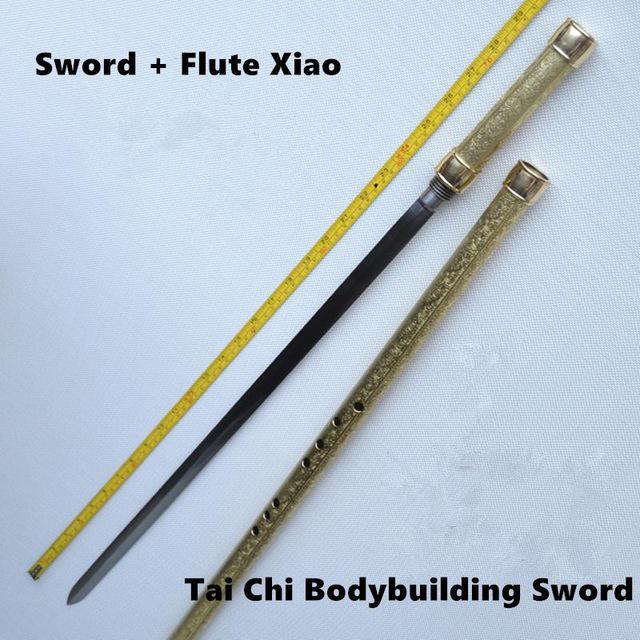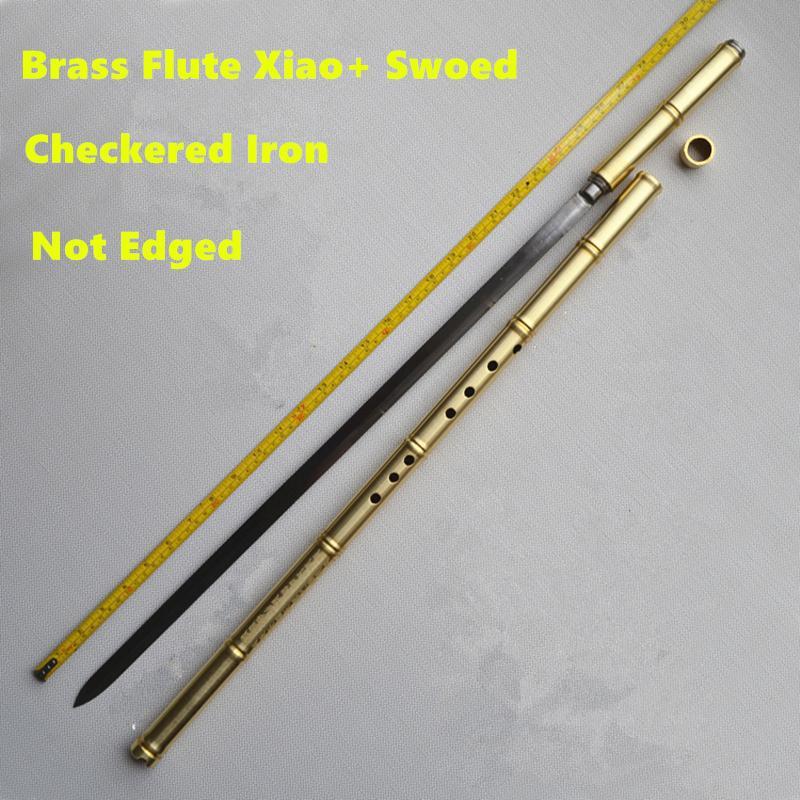The first image is the image on the left, the second image is the image on the right. Evaluate the accuracy of this statement regarding the images: "The left image shows only a flute displayed at an angle, and the right image shows a measuring tape, a sword and a flute displayed diagonally.". Is it true? Answer yes or no. No. The first image is the image on the left, the second image is the image on the right. Considering the images on both sides, is "There are more instruments in the image on the right." valid? Answer yes or no. No. 